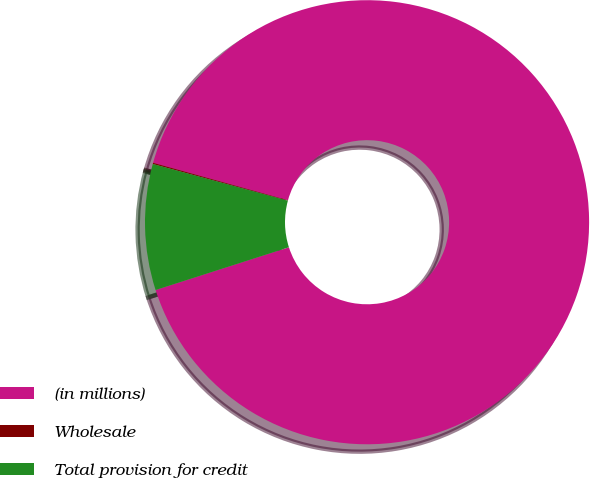Convert chart. <chart><loc_0><loc_0><loc_500><loc_500><pie_chart><fcel>(in millions)<fcel>Wholesale<fcel>Total provision for credit<nl><fcel>90.75%<fcel>0.09%<fcel>9.16%<nl></chart> 